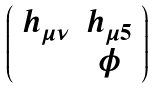Convert formula to latex. <formula><loc_0><loc_0><loc_500><loc_500>\left ( \begin{array} { c c } h _ { \mu \nu } & h _ { \mu 5 } \\ & \phi \end{array} \right )</formula> 